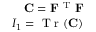Convert formula to latex. <formula><loc_0><loc_0><loc_500><loc_500>\begin{array} { r } { C = F ^ { T } F } \\ { I _ { 1 } = T r ( C ) } \end{array}</formula> 